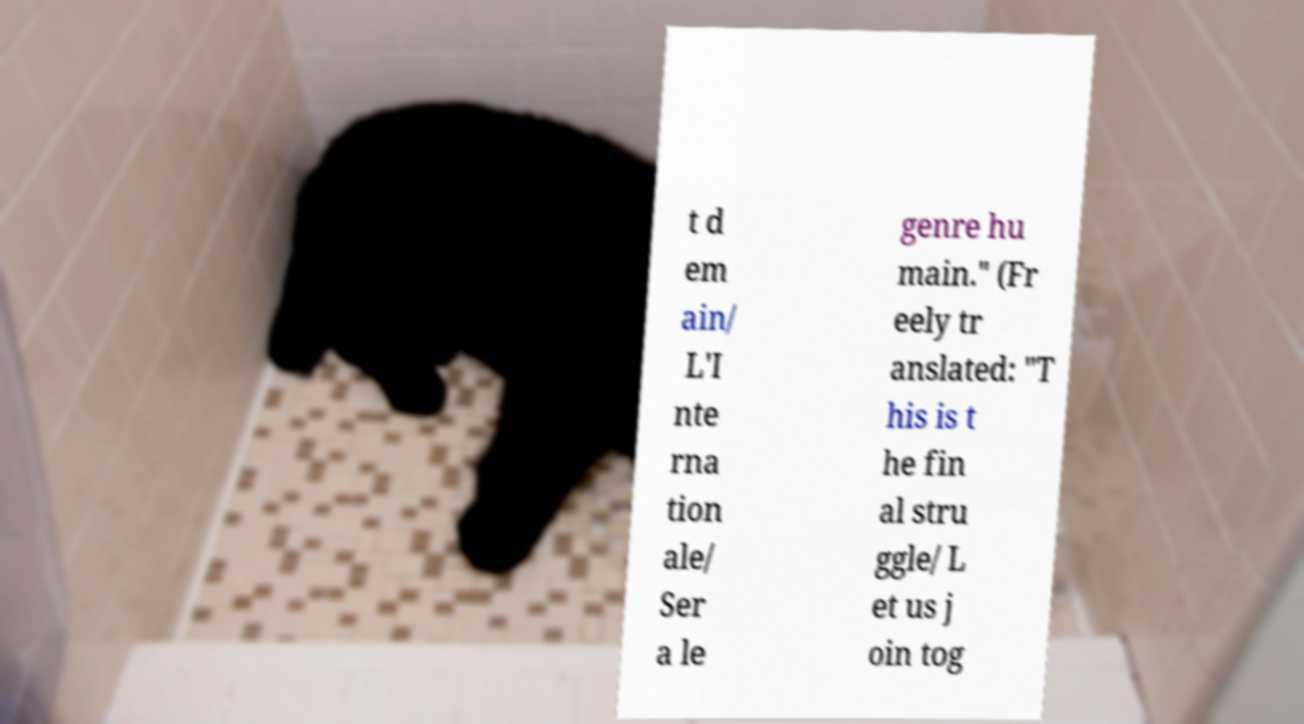For documentation purposes, I need the text within this image transcribed. Could you provide that? t d em ain/ L'I nte rna tion ale/ Ser a le genre hu main." (Fr eely tr anslated: "T his is t he fin al stru ggle/ L et us j oin tog 